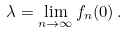<formula> <loc_0><loc_0><loc_500><loc_500>\lambda = \lim _ { n \to \infty } f _ { n } ( 0 ) \, .</formula> 